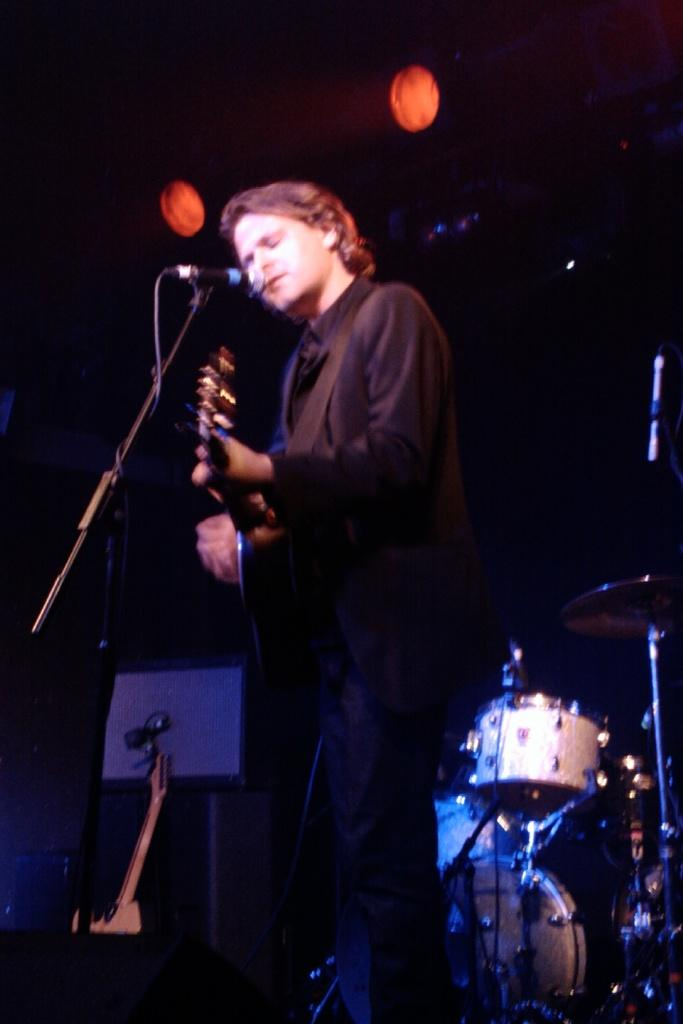What is the main subject of the image? There is a person standing in the center of the image. What is the person holding in the image? The person is holding a guitar. What object is in front of the person? There is a microphone in front of the person. What can be seen in the background of the image? There are musical instruments and lighting visible in the background. What type of skin condition does the person have in the image? There is no indication of a skin condition in the image; the person's skin is not visible. 